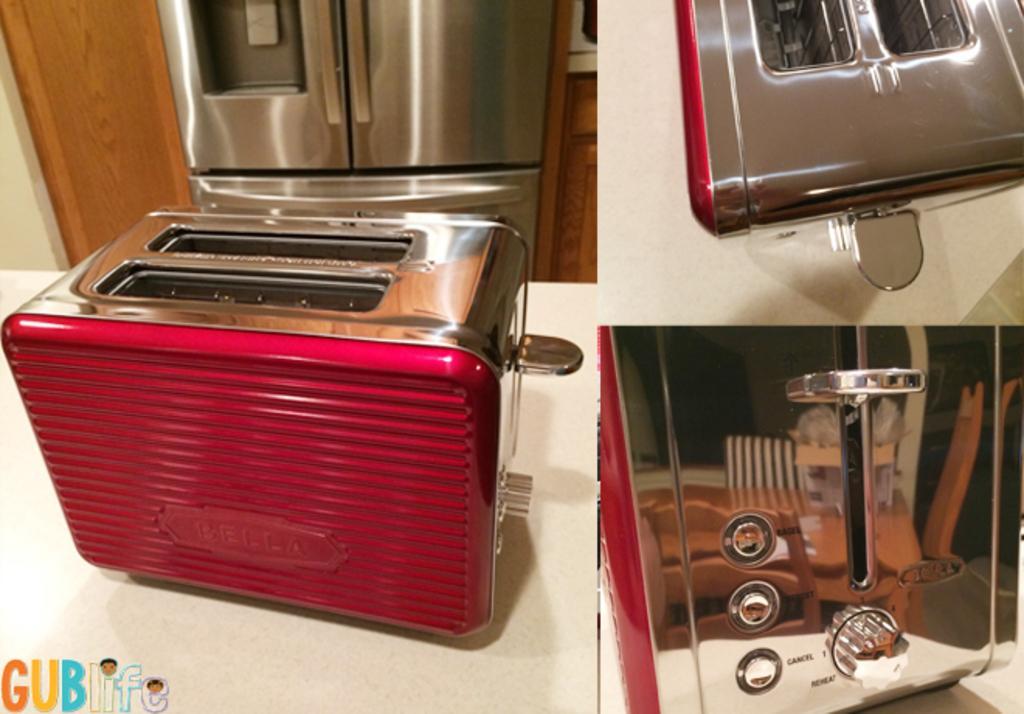Can you describe this image briefly? In this image there are toasters on the surface, there is a microwave oven truncated, there is text in the left corner of the image. 